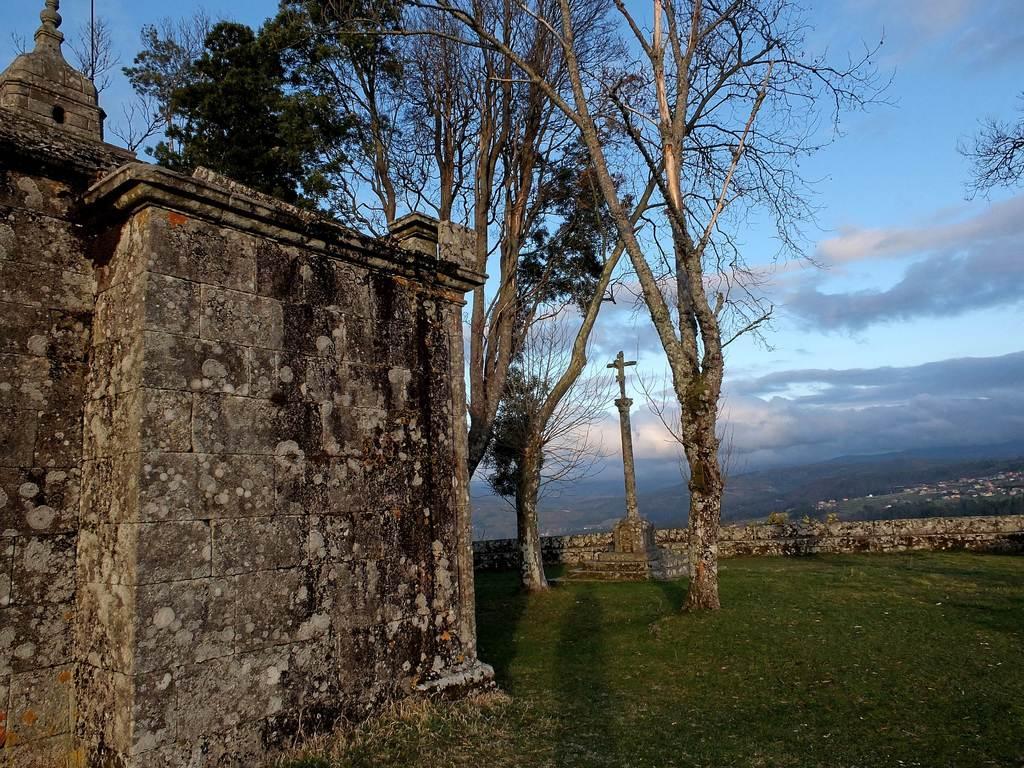Can you describe this image briefly? This picture is taken from outside of the city. In this image, on the left side, we can see a building. In the middle of the image, we can see some trees, pillar, cross. On the right side, we can see some buildings, trees and a wall. At the top, we can see a sky which is a bit cloudy, at the bottom, we can see a grass. 